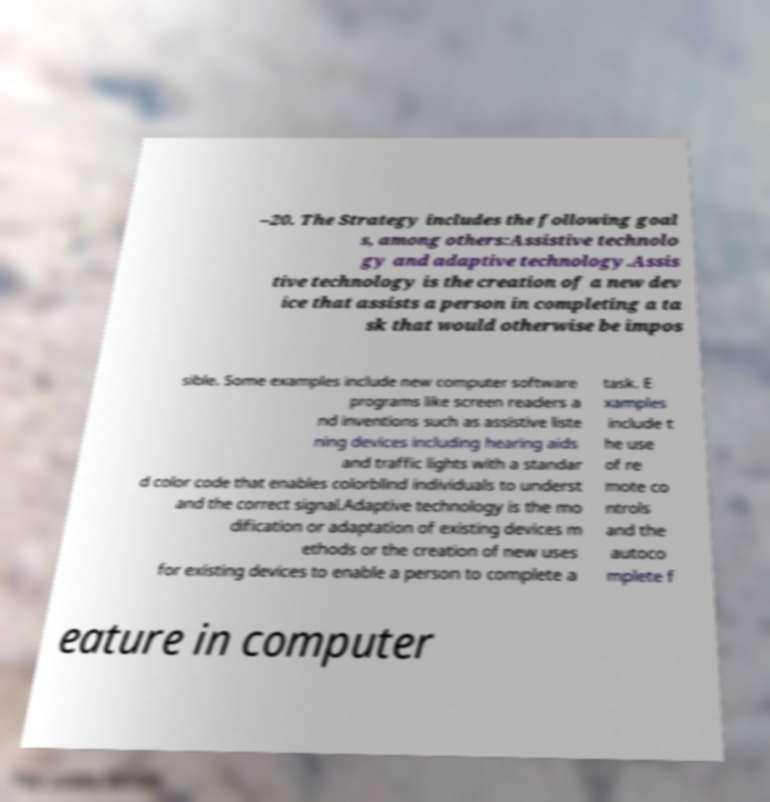I need the written content from this picture converted into text. Can you do that? –20. The Strategy includes the following goal s, among others:Assistive technolo gy and adaptive technology.Assis tive technology is the creation of a new dev ice that assists a person in completing a ta sk that would otherwise be impos sible. Some examples include new computer software programs like screen readers a nd inventions such as assistive liste ning devices including hearing aids and traffic lights with a standar d color code that enables colorblind individuals to underst and the correct signal.Adaptive technology is the mo dification or adaptation of existing devices m ethods or the creation of new uses for existing devices to enable a person to complete a task. E xamples include t he use of re mote co ntrols and the autoco mplete f eature in computer 